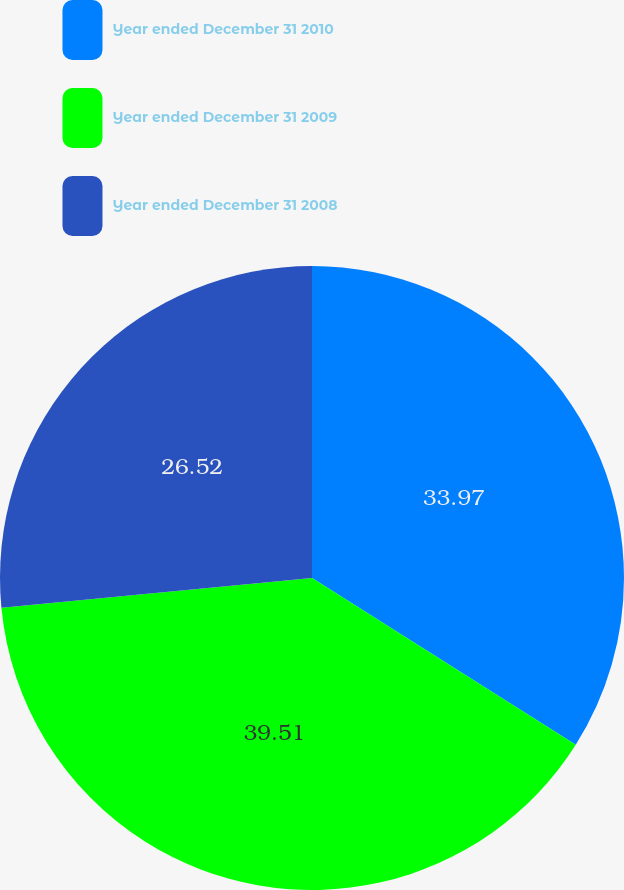Convert chart to OTSL. <chart><loc_0><loc_0><loc_500><loc_500><pie_chart><fcel>Year ended December 31 2010<fcel>Year ended December 31 2009<fcel>Year ended December 31 2008<nl><fcel>33.97%<fcel>39.51%<fcel>26.52%<nl></chart> 